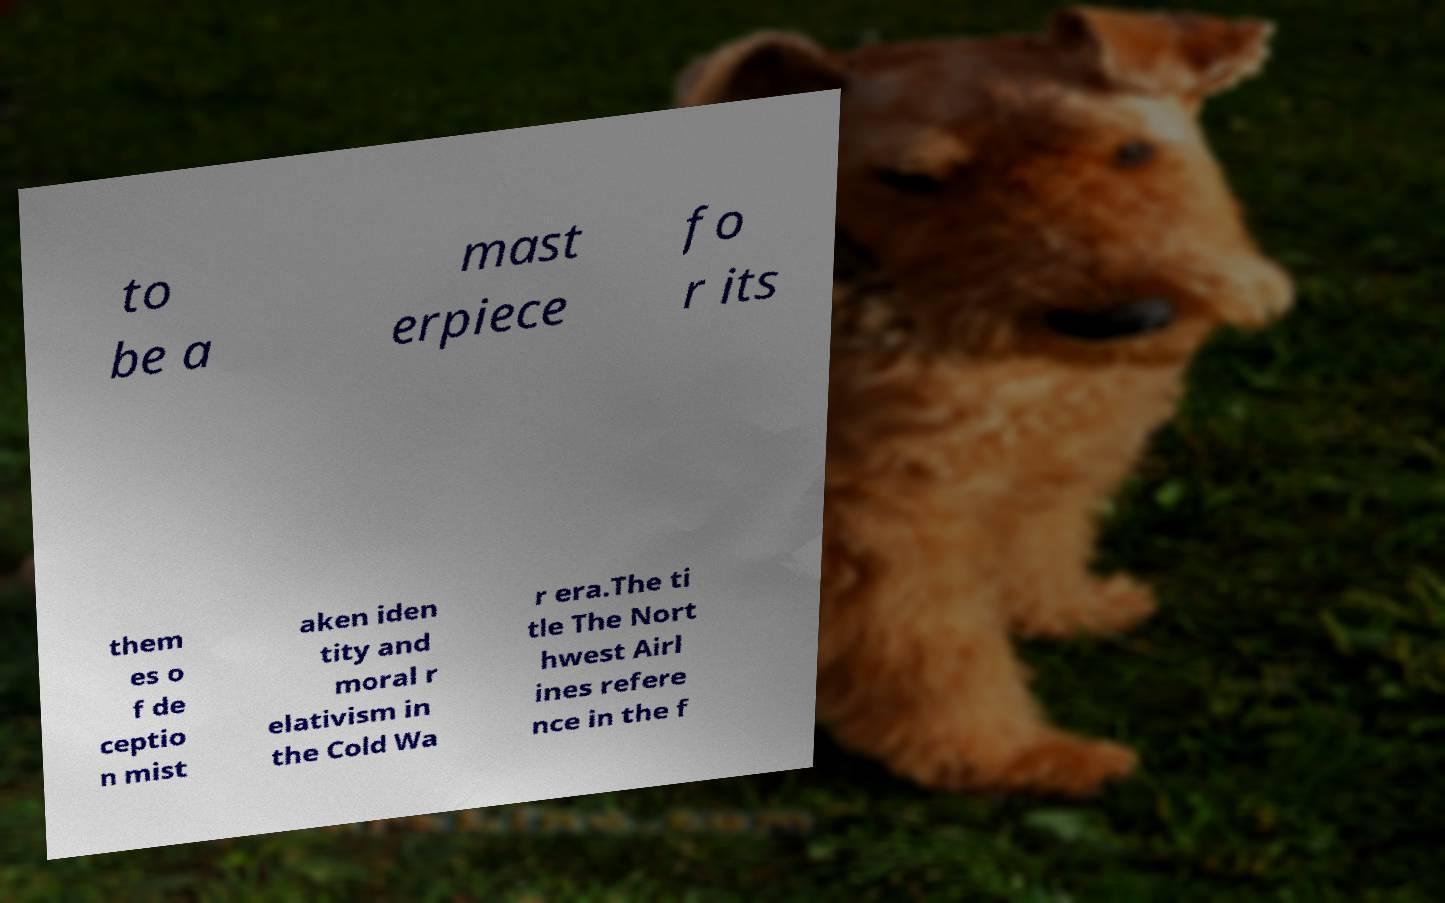I need the written content from this picture converted into text. Can you do that? to be a mast erpiece fo r its them es o f de ceptio n mist aken iden tity and moral r elativism in the Cold Wa r era.The ti tle The Nort hwest Airl ines refere nce in the f 